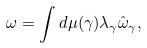<formula> <loc_0><loc_0><loc_500><loc_500>\omega = \int d \mu ( \gamma ) \lambda _ { \gamma } \hat { \omega } _ { \gamma } ,</formula> 